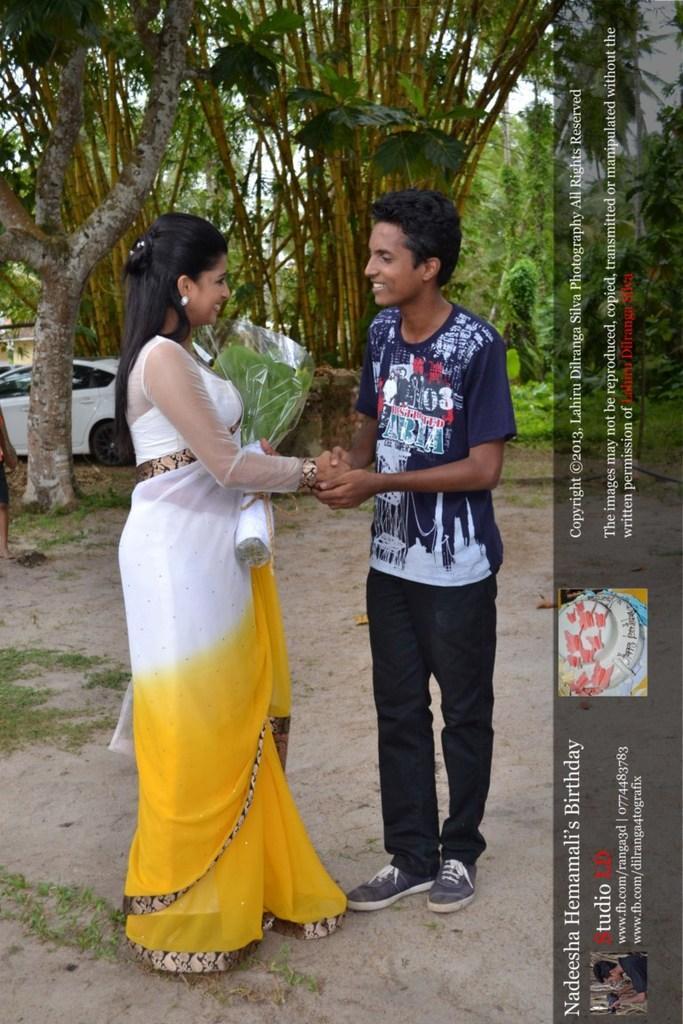Please provide a concise description of this image. In this picture we can see there are two people standing and the woman is holding a bouquet. Behind the people there are trees, plants a car and the sky. On the image there is a watermark. 